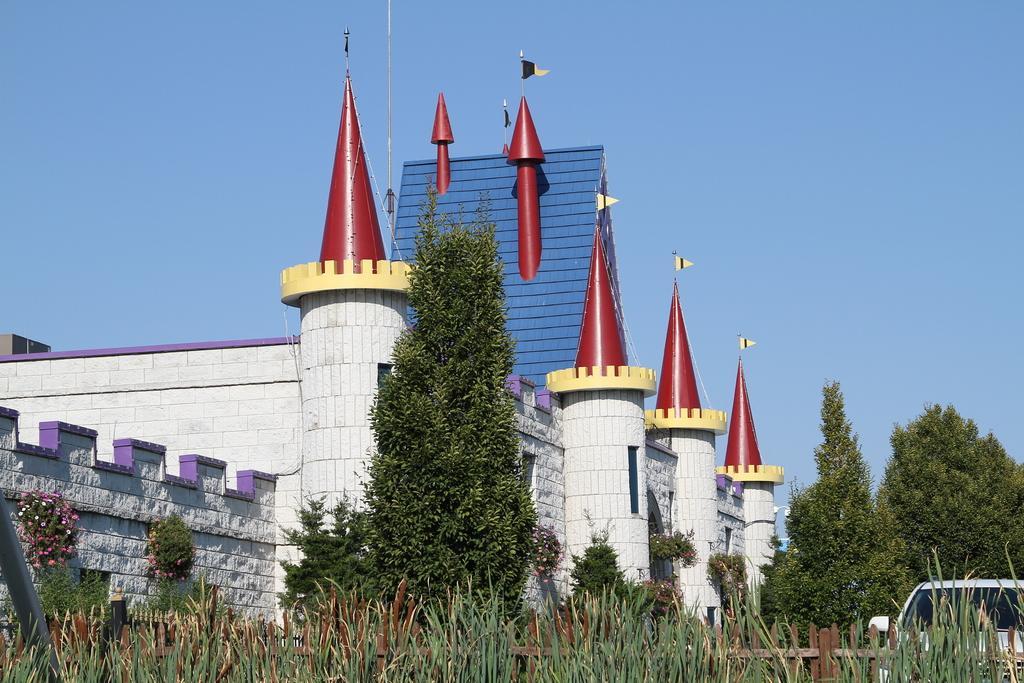Can you describe this image briefly? In the foreground of this image, there are plants, wooden railing and trees. We can also see a vehicle on the right bottom. In the middle, there is a castle and the flags on it. At the top, there is the sky. 